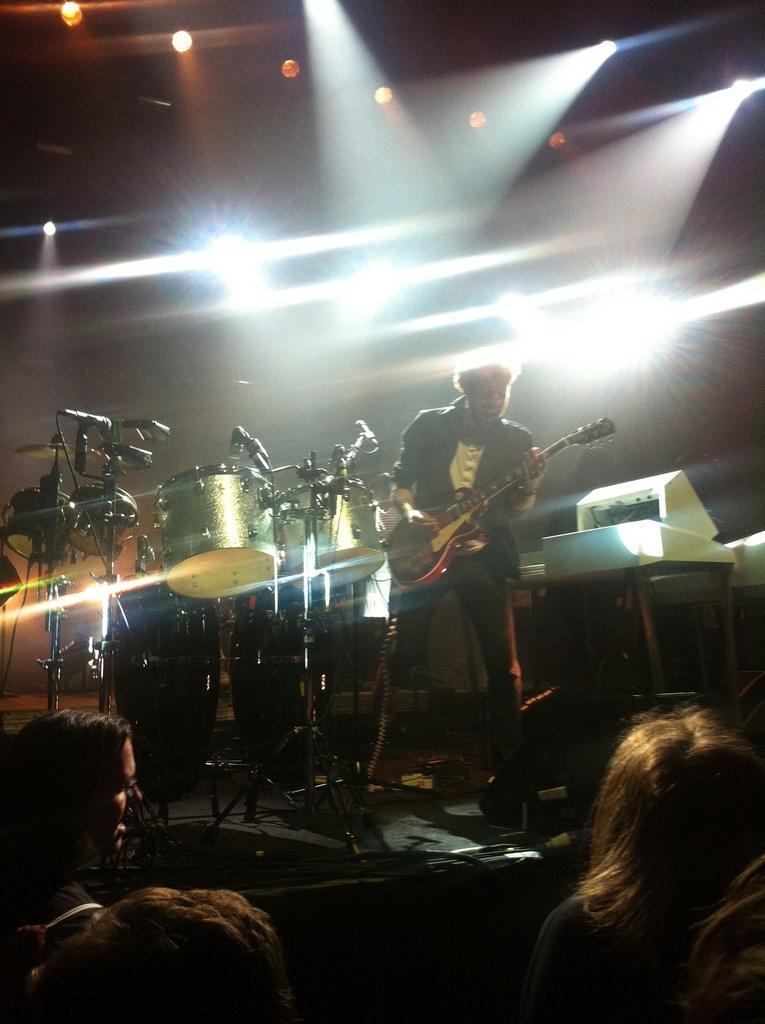Could you give a brief overview of what you see in this image? In the image we can see there is a person who is standing and holding guitar in his hand and at the back of him there are musical instruments and in front of him there are people who are looking at him. 